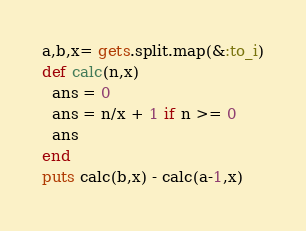<code> <loc_0><loc_0><loc_500><loc_500><_Ruby_>a,b,x= gets.split.map(&:to_i)
def calc(n,x)
  ans = 0
  ans = n/x + 1 if n >= 0
  ans
end
puts calc(b,x) - calc(a-1,x)</code> 